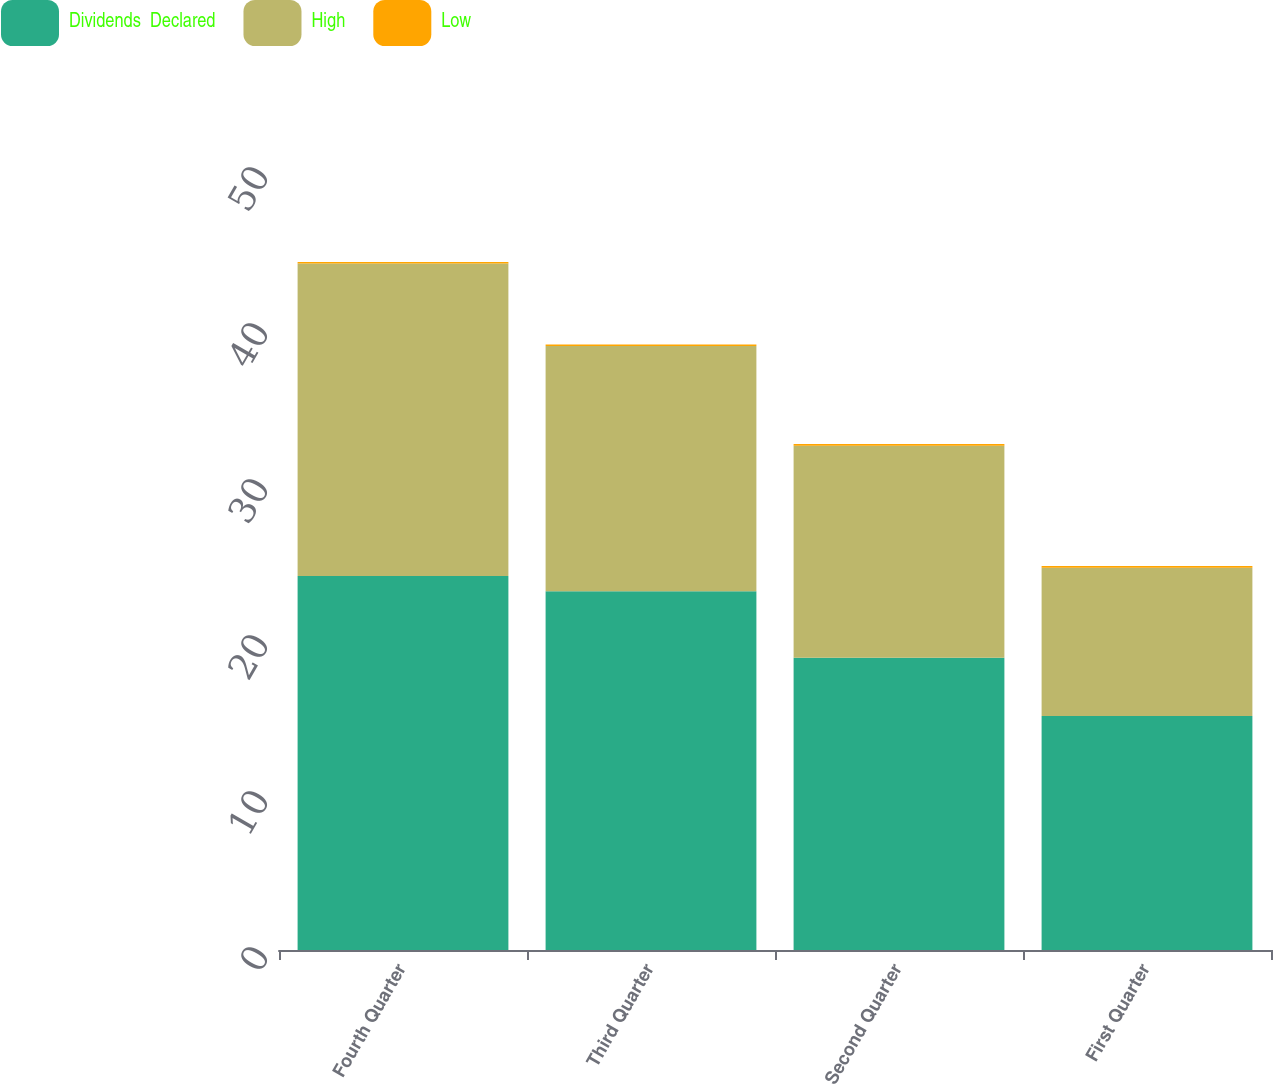Convert chart to OTSL. <chart><loc_0><loc_0><loc_500><loc_500><stacked_bar_chart><ecel><fcel>Fourth Quarter<fcel>Third Quarter<fcel>Second Quarter<fcel>First Quarter<nl><fcel>Dividends  Declared<fcel>23.97<fcel>23<fcel>18.73<fcel>15<nl><fcel>High<fcel>20.04<fcel>15.72<fcel>13.6<fcel>9.51<nl><fcel>Low<fcel>0.1<fcel>0.1<fcel>0.1<fcel>0.1<nl></chart> 